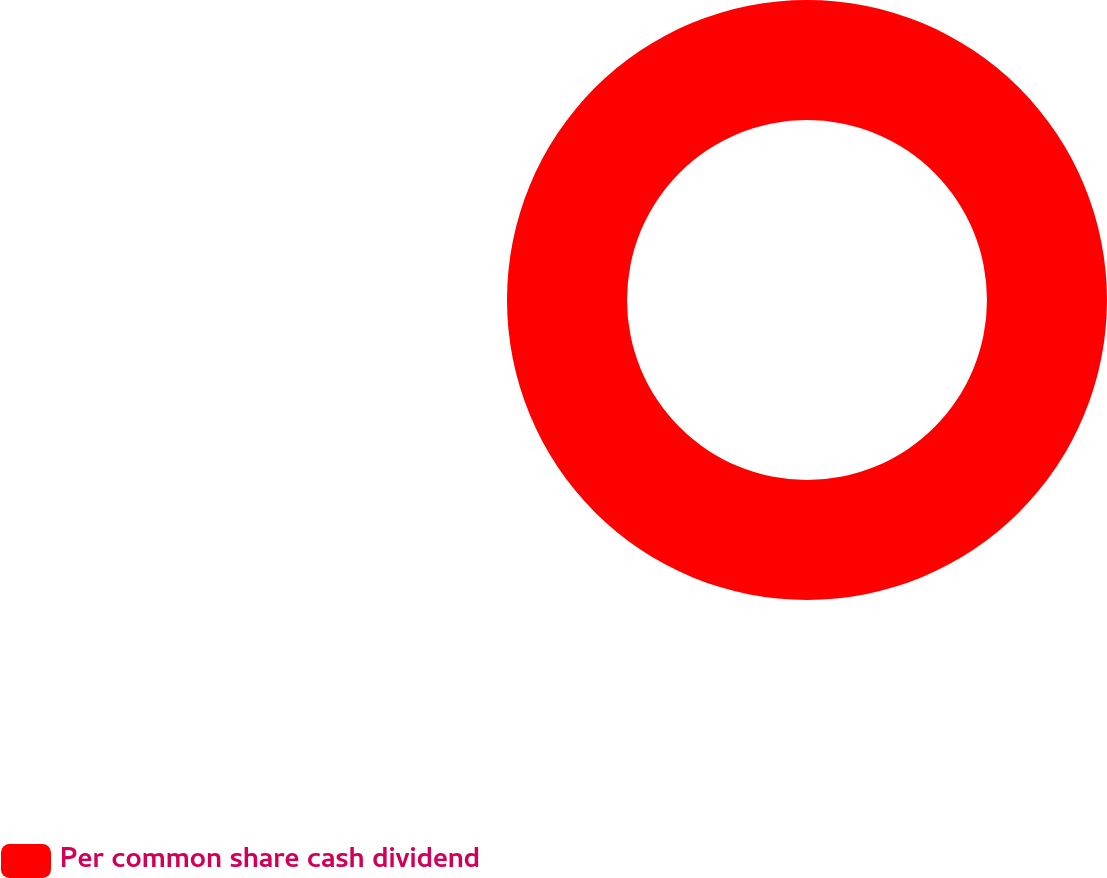Convert chart to OTSL. <chart><loc_0><loc_0><loc_500><loc_500><pie_chart><fcel>Per common share cash dividend<nl><fcel>100.0%<nl></chart> 